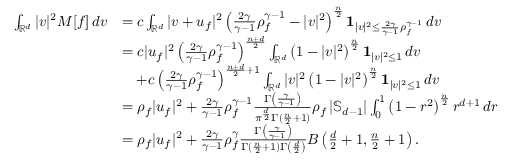<formula> <loc_0><loc_0><loc_500><loc_500>\begin{array} { r l } { \int _ { \mathbb { R } ^ { d } } | v | ^ { 2 } M [ f ] \, d v } & { = c \int _ { \mathbb { R } ^ { d } } | v + u _ { f } | ^ { 2 } \left ( \frac { 2 \gamma } { \gamma - 1 } \rho _ { f } ^ { \gamma - 1 } - | v | ^ { 2 } \right ) ^ { \frac { n } { 2 } } 1 _ { | v | ^ { 2 } \leq \frac { 2 \gamma } { \gamma - 1 } \rho _ { f } ^ { \gamma - 1 } } \, d v } \\ & { = c | u _ { f } | ^ { 2 } \left ( \frac { 2 \gamma } { \gamma - 1 } \rho _ { f } ^ { \gamma - 1 } \right ) ^ { \frac { n + d } { 2 } } \int _ { \mathbb { R } ^ { d } } \left ( 1 - | v | ^ { 2 } \right ) ^ { \frac { n } { 2 } } 1 _ { | v | ^ { 2 } \leq 1 } \, d v } \\ & { \quad + c \left ( \frac { 2 \gamma } { \gamma - 1 } \rho _ { f } ^ { \gamma - 1 } \right ) ^ { \frac { n + d } { 2 } + 1 } \int _ { \mathbb { R } ^ { d } } | v | ^ { 2 } \left ( 1 - | v | ^ { 2 } \right ) ^ { \frac { n } { 2 } } 1 _ { | v | ^ { 2 } \leq 1 } \, d v } \\ & { = \rho _ { f } | u _ { f } | ^ { 2 } + \frac { 2 \gamma } { \gamma - 1 } \rho _ { f } ^ { \gamma - 1 } \frac { \Gamma \left ( \frac { \gamma } { \gamma - 1 } \right ) } { \pi ^ { \frac { d } { 2 } } \Gamma ( \frac { n } { 2 } + 1 ) } \rho _ { f } \left | \mathbb { S } _ { d - 1 } \right | \int _ { 0 } ^ { 1 } \left ( 1 - r ^ { 2 } \right ) ^ { \frac { n } { 2 } } r ^ { d + 1 } \, d r } \\ & { = \rho _ { f } | u _ { f } | ^ { 2 } + \frac { 2 \gamma } { \gamma - 1 } \rho _ { f } ^ { \gamma } \frac { \Gamma \left ( \frac { \gamma } { \gamma - 1 } \right ) } { \Gamma ( \frac { n } { 2 } + 1 ) \Gamma \left ( \frac { d } { 2 } \right ) } B \left ( \frac { d } { 2 } + 1 , \frac { n } { 2 } + 1 \right ) . } \end{array}</formula> 